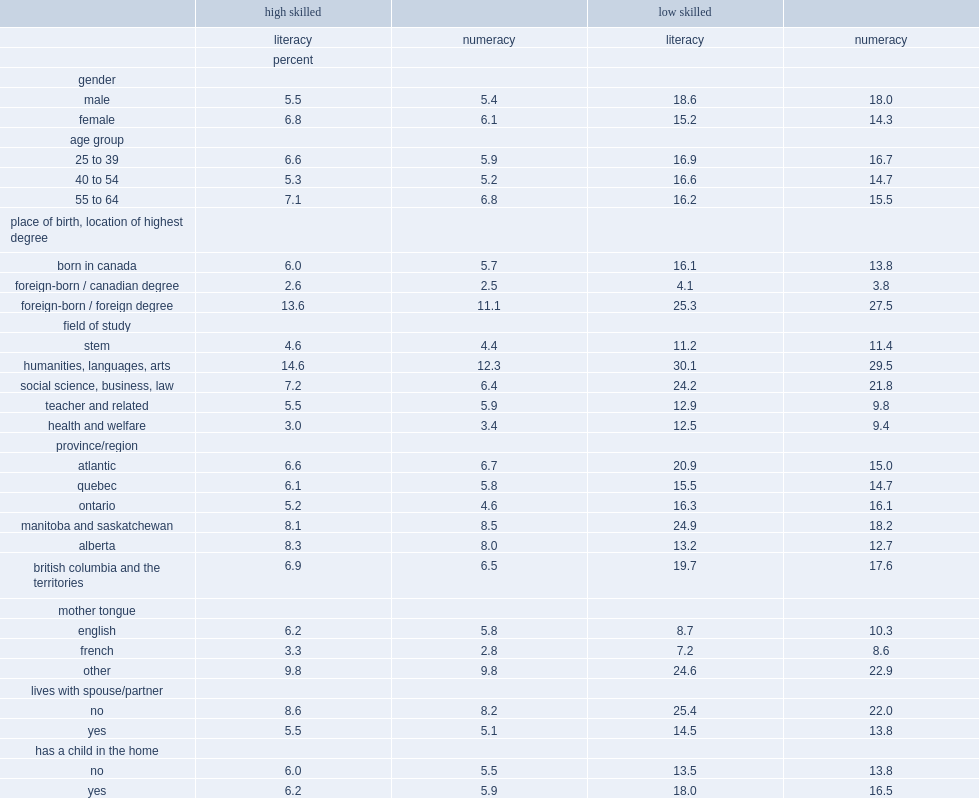Among those who had higher literacy skills,who were more likely to be overqualified, foreign-born workers who received their highest university degree outside canada or canadian-born workers? Foreign-born / foreign degree. Among those who had higher literacy skills,who had the lowest probability of being overqualified. Foreign-born / canadian degree. Within the lower skilled population of the numeracy model,what were the percentages of foreign-born workers who earned their degree in canada and those who were born in canada respectively? 3.8 13.8. Within the lower skilled population in both models,what were the probabilities of the foreign-born and foreign-educated had respectively? 25.3 27.5. Within the higher skilled population in both models,who had greater probability of being overqualified,graduates of humanities, languages and arts programs or graduates of stem programs respectively? Humanities, languages, arts. Among workers with higher literacy skills,what was the gap between graduates of humanities, languages and arts programs and graduates of stem programs. 10. Among workers with lower literacy skills,who had a significantly greater probability of being overqualified,graduates of social science, business and law programs or their lower-skilled counterparts in stem programs. Social science, business, law. Among university graduates with higher literacy levels,who were the least likely to be overqualified. French. Among graduates with lower skill levels,what was the percentage of those whose mother tongue was a language other than english or french? 24.6. 